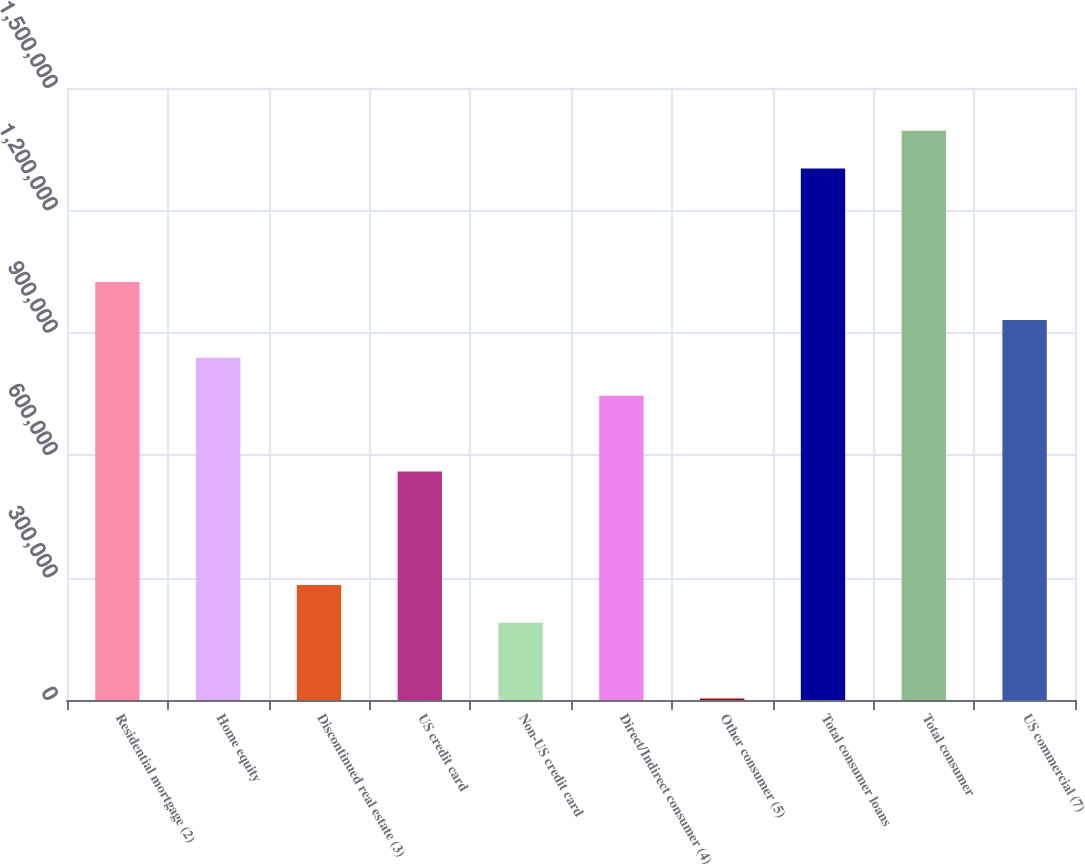Convert chart to OTSL. <chart><loc_0><loc_0><loc_500><loc_500><bar_chart><fcel>Residential mortgage (2)<fcel>Home equity<fcel>Discontinued real estate (3)<fcel>US credit card<fcel>Non-US credit card<fcel>Direct/Indirect consumer (4)<fcel>Other consumer (5)<fcel>Total consumer loans<fcel>Total consumer<fcel>US commercial (7)<nl><fcel>1.02425e+06<fcel>838646<fcel>281843<fcel>560244<fcel>189043<fcel>745845<fcel>3442<fcel>1.30265e+06<fcel>1.39545e+06<fcel>931446<nl></chart> 